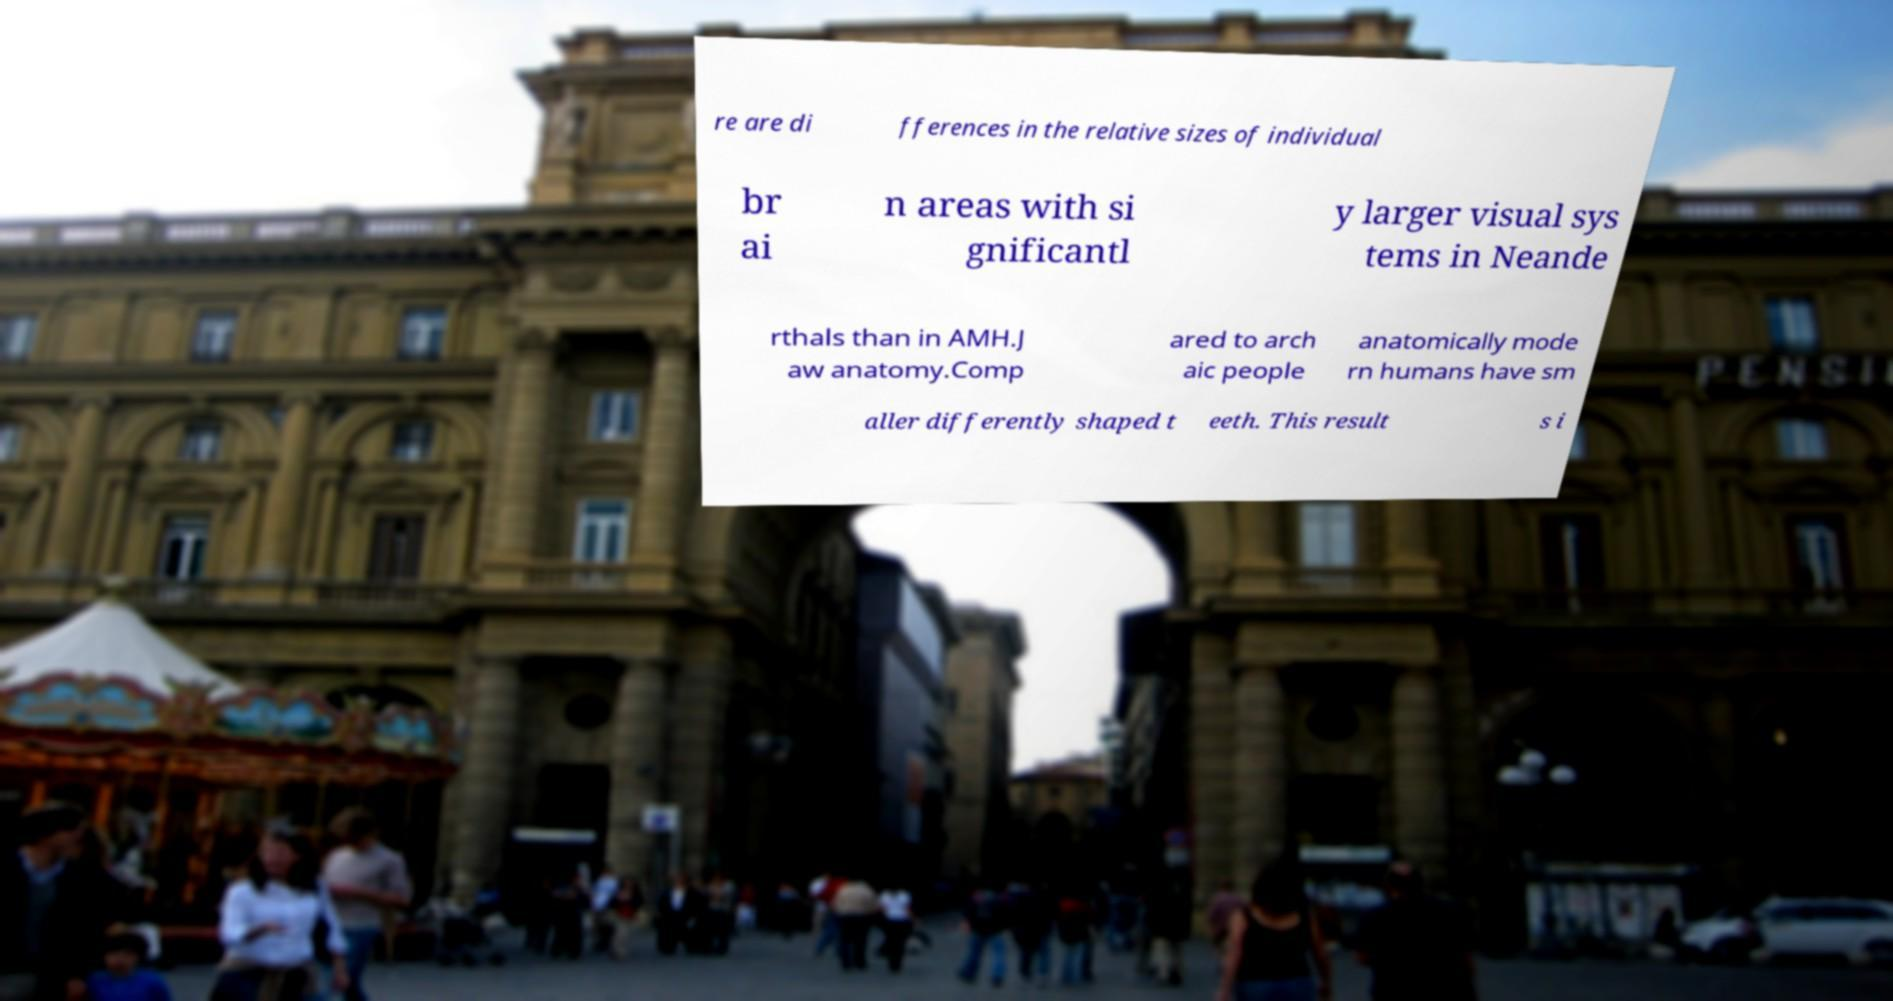Please read and relay the text visible in this image. What does it say? re are di fferences in the relative sizes of individual br ai n areas with si gnificantl y larger visual sys tems in Neande rthals than in AMH.J aw anatomy.Comp ared to arch aic people anatomically mode rn humans have sm aller differently shaped t eeth. This result s i 